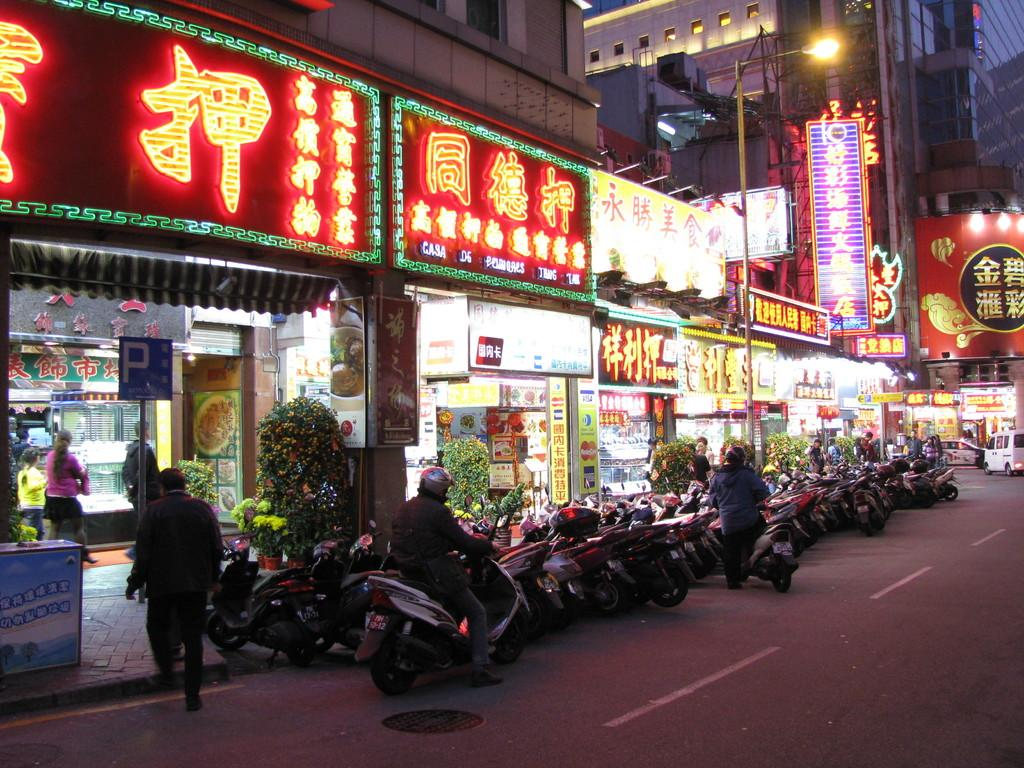What type of vehicles are in the image? There is a group of bikes in the image. What is the current state of the bikes in the image? The bikes are parked. What type of establishments are in the image? There is a group of stores in the image. Where are the bikes located in relation to the stores? The bikes are parked in front of the stores. What type of fruit is being sold in the stores in the image? There is no information about the stores selling fruit in the image. Is there a bomb visible in the image? There is no bomb present in the image. 